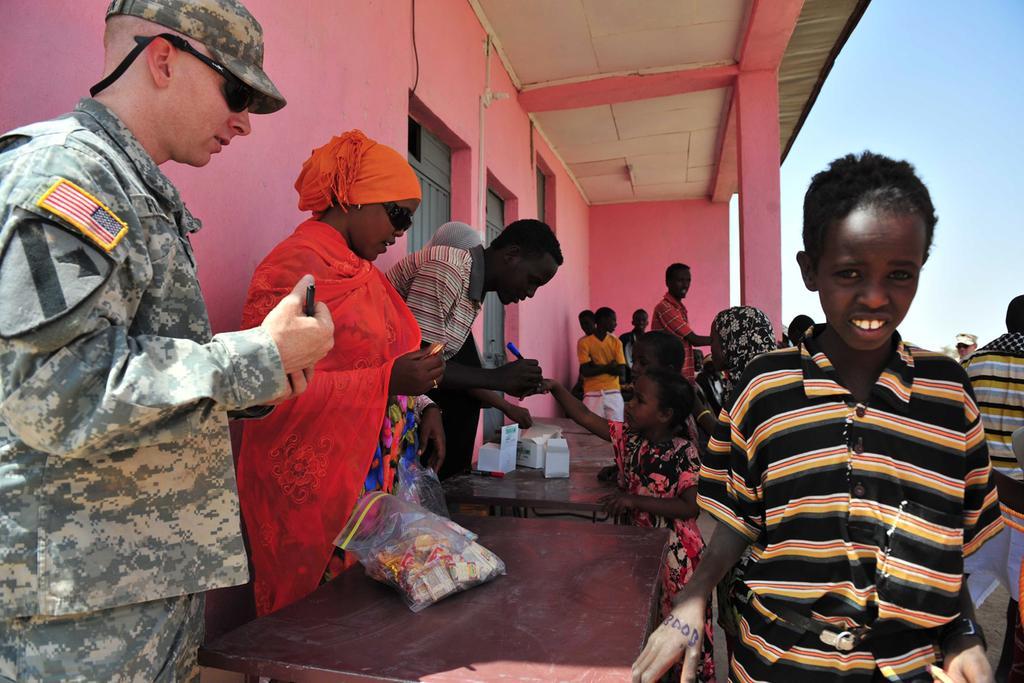Describe this image in one or two sentences. In this image I can see a person wearing military uniform is standing and holding a black colored object in his hand and a boy wearing green and yellow t shirt is standing in front of him. I can see a table and few objects on the table. In the background I can see number of people standing, a building which is pink in color, few windows and the sky. 